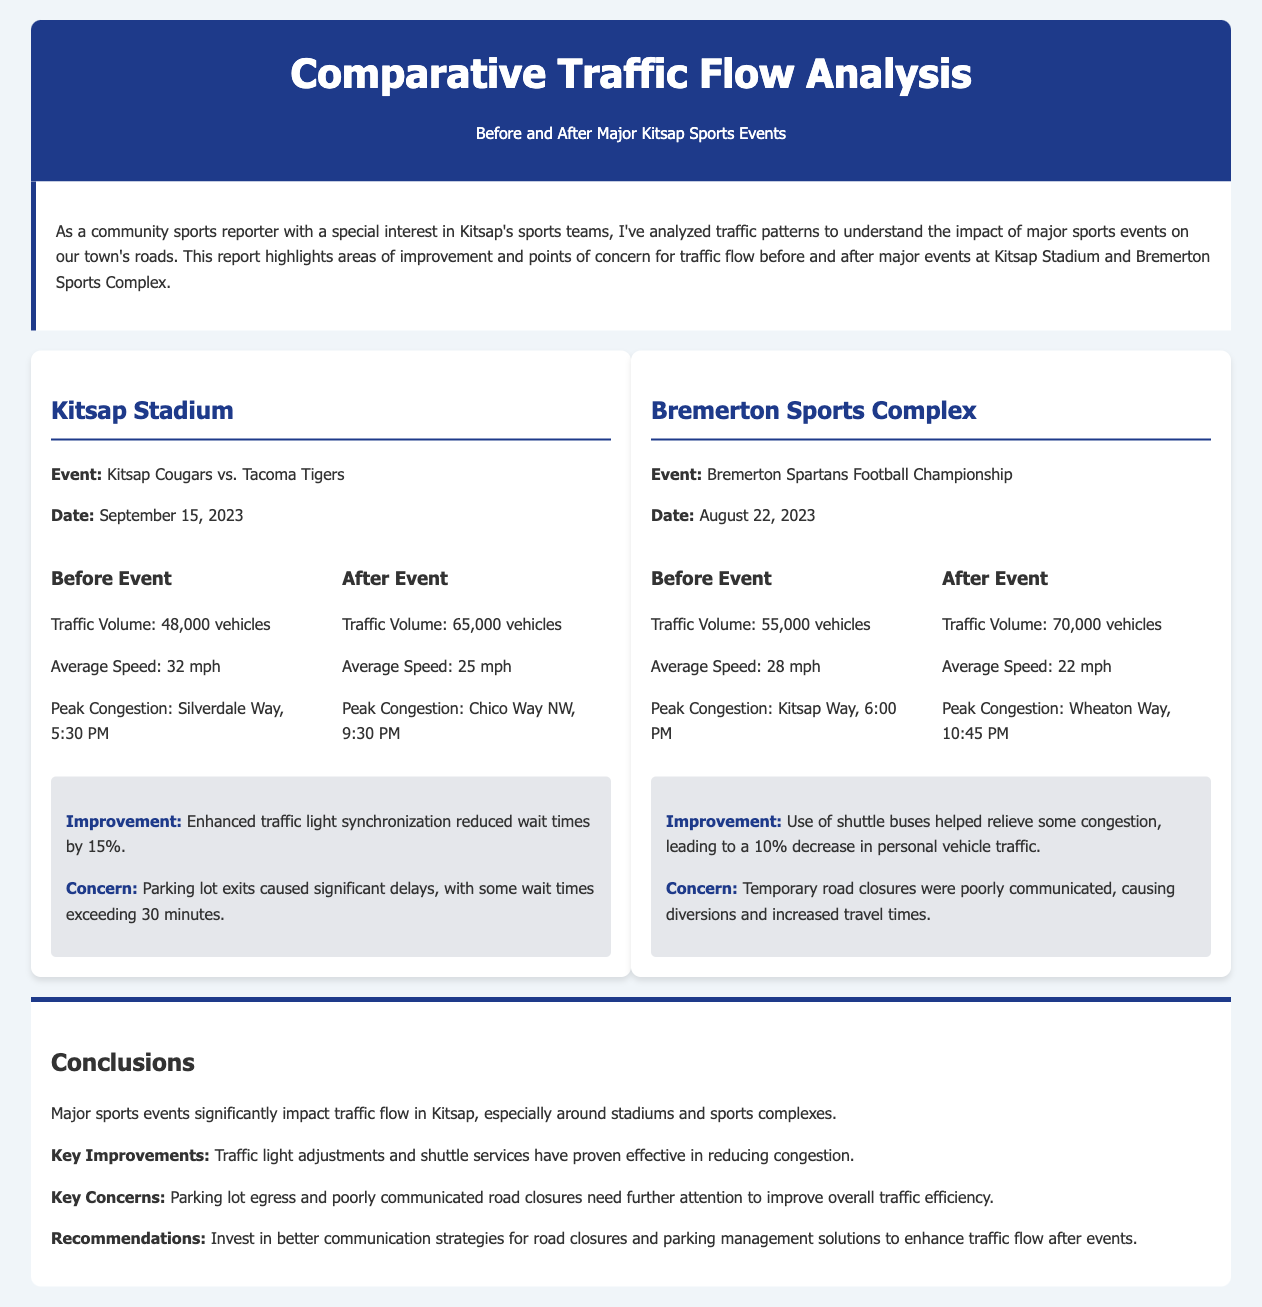What was the traffic volume before the Kitsap Stadium event? The traffic volume before the Kitsap Stadium event is stated in the section detailing event data.
Answer: 48,000 vehicles What was the peak congestion time after the Bremerton Sports Complex event? The peak congestion time after the Bremerton Sports Complex event is mentioned in the after-event traffic data.
Answer: 10:45 PM What percentage did shuttle buses decrease personal vehicle traffic at the Bremerton Sports Complex? The decrease in personal vehicle traffic due to shuttle buses is specified in the observations under the Bremerton Sports Complex event.
Answer: 10% What was the average speed after the Kitsap Stadium event? The average speed after the Kitsap Stadium event is provided in the traffic data for that event.
Answer: 25 mph Where was the peak congestion noted before the Bremerton Sports Complex event? The location of peak congestion before the Bremerton Sports Complex event is provided in the before-event traffic data.
Answer: Kitsap Way What was a notable improvement observed after the Kitsap Stadium event? The notable improvement after the Kitsap Stadium event is highlighted in the observations section.
Answer: Enhanced traffic light synchronization What was the parking exit wait time after the Kitsap Stadium event? The wait time for parking lot exits after the Kitsap Stadium event is mentioned in the observations.
Answer: Exceeding 30 minutes What is a key concern mentioned for the Bremerton Sports Complex event? The key concern for the Bremerton Sports Complex event is detailed in the observations section.
Answer: Poorly communicated road closures 